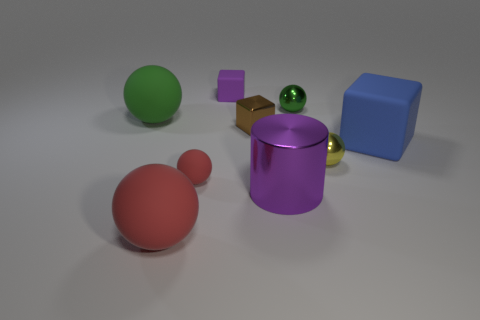What shape is the small brown object?
Your answer should be compact. Cube. What number of things are big matte things or small purple blocks?
Ensure brevity in your answer.  4. There is a tiny ball that is behind the yellow sphere; does it have the same color as the tiny rubber thing that is behind the big green ball?
Ensure brevity in your answer.  No. How many other objects are the same shape as the small yellow object?
Provide a short and direct response. 4. Are there any tiny rubber cubes?
Provide a succinct answer. Yes. What number of things are either green metallic spheres or metal balls that are behind the large green ball?
Your answer should be very brief. 1. Do the blue rubber object to the right of the purple metal thing and the brown metal thing have the same size?
Keep it short and to the point. No. How many other things are the same size as the brown metallic cube?
Make the answer very short. 4. What color is the big metal cylinder?
Make the answer very short. Purple. What is the tiny sphere behind the yellow ball made of?
Provide a succinct answer. Metal. 